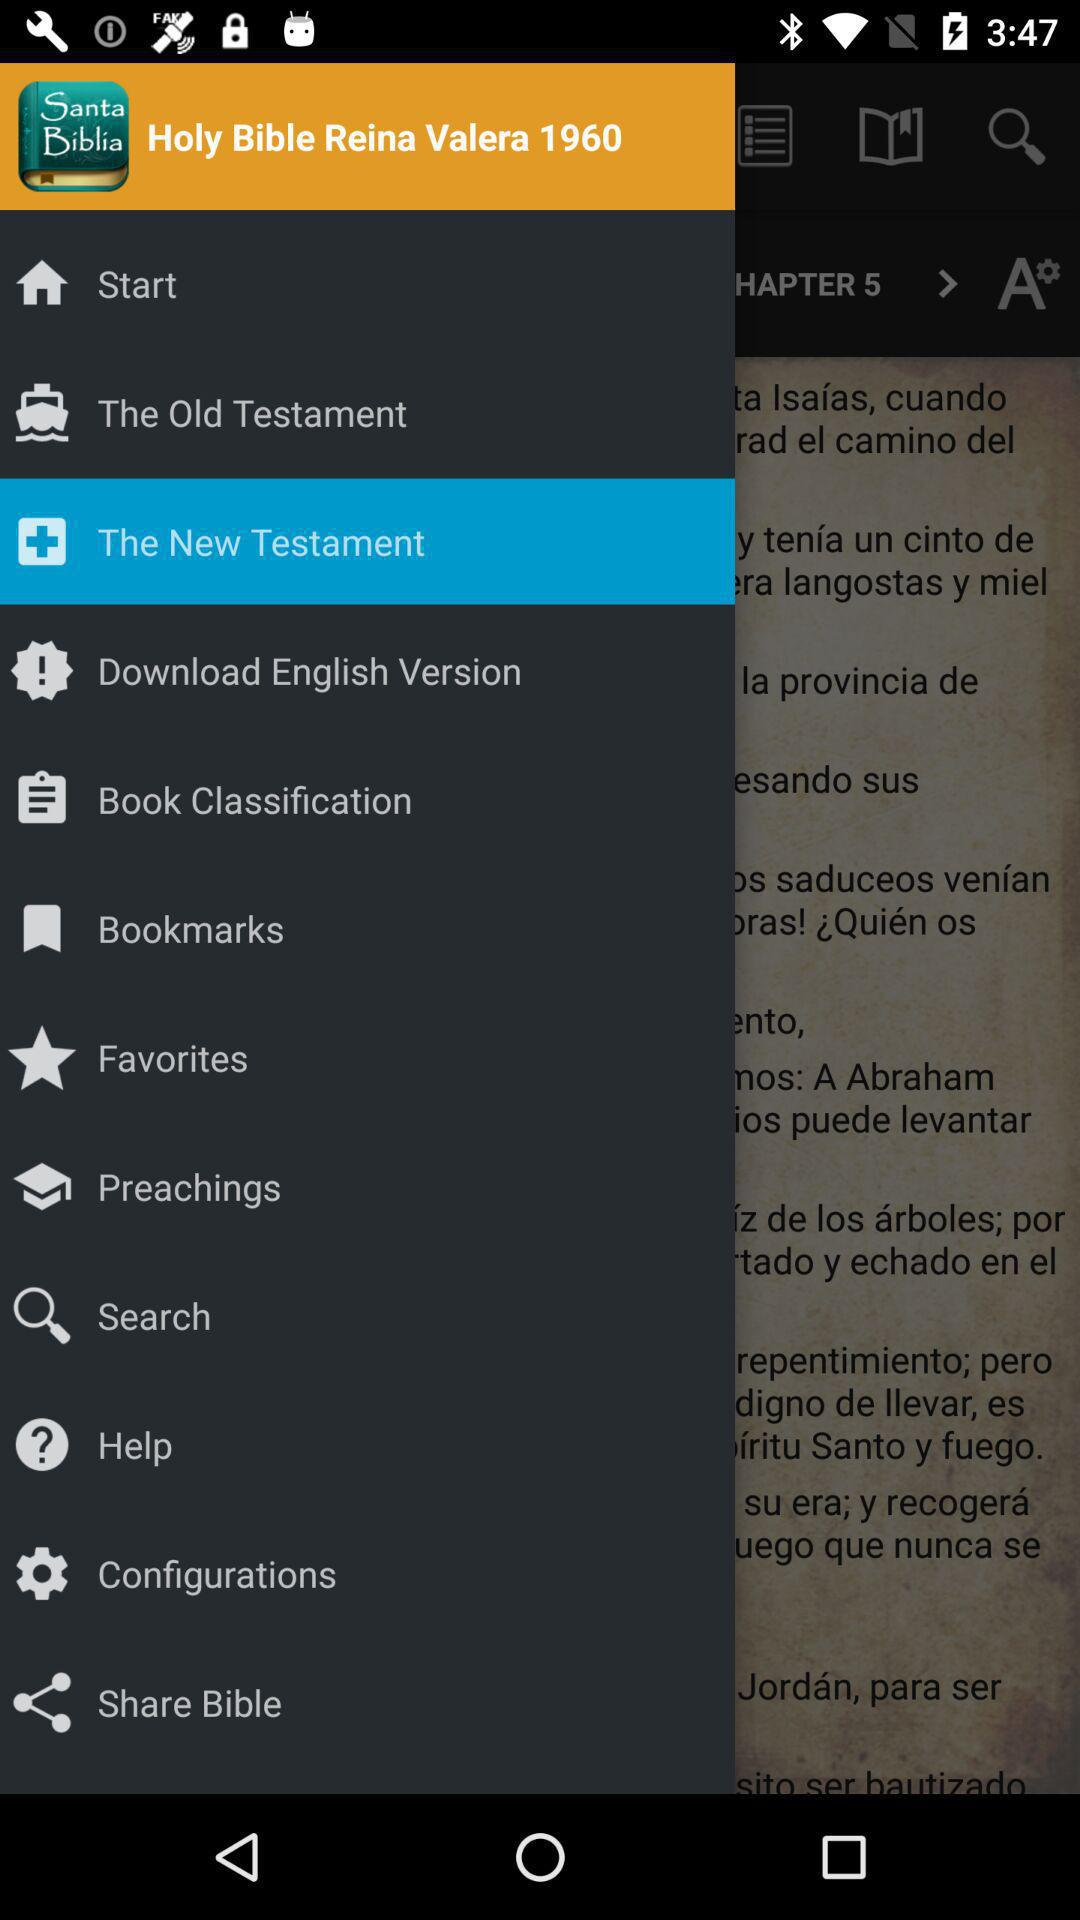What is the application name? The application name is "Holy Bible Reina Valera 1960". 